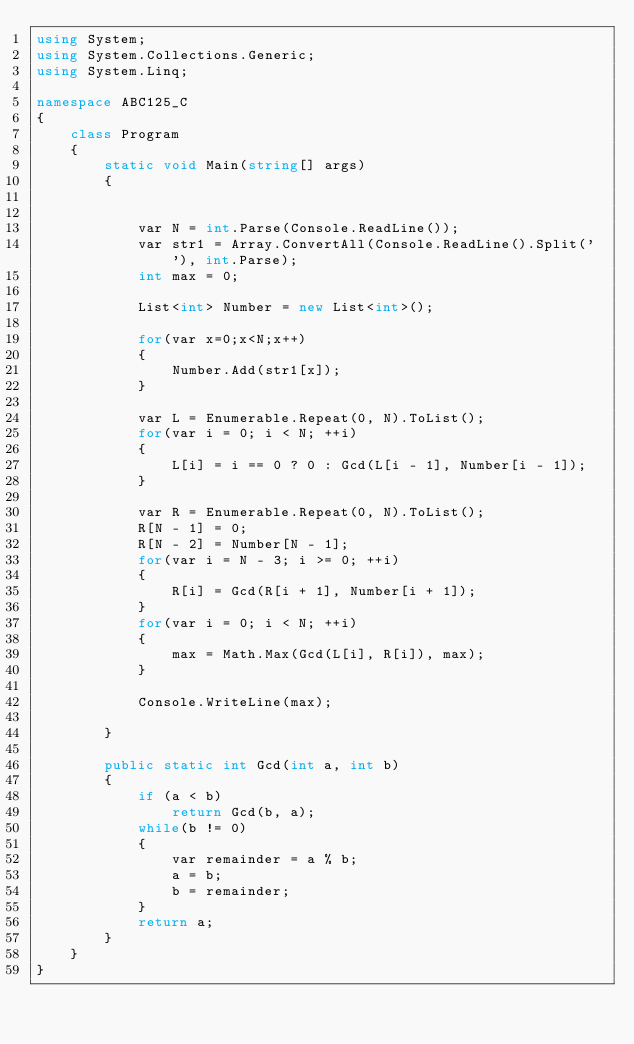Convert code to text. <code><loc_0><loc_0><loc_500><loc_500><_C#_>using System;
using System.Collections.Generic;
using System.Linq;

namespace ABC125_C
{
    class Program
    {
        static void Main(string[] args)
        {
            
            
            var N = int.Parse(Console.ReadLine());
            var str1 = Array.ConvertAll(Console.ReadLine().Split(' '), int.Parse);
            int max = 0;

            List<int> Number = new List<int>();
            
            for(var x=0;x<N;x++)
            {
                Number.Add(str1[x]);
            }

            var L = Enumerable.Repeat(0, N).ToList();
            for(var i = 0; i < N; ++i)
            {
                L[i] = i == 0 ? 0 : Gcd(L[i - 1], Number[i - 1]);
            }

            var R = Enumerable.Repeat(0, N).ToList();
            R[N - 1] = 0;
            R[N - 2] = Number[N - 1];
            for(var i = N - 3; i >= 0; ++i)
            {
                R[i] = Gcd(R[i + 1], Number[i + 1]);
            }
            for(var i = 0; i < N; ++i)
            {
                max = Math.Max(Gcd(L[i], R[i]), max);
            }

            Console.WriteLine(max);

        }

        public static int Gcd(int a, int b)
        {
            if (a < b)
                return Gcd(b, a);
            while(b != 0)
            {
                var remainder = a % b;
                a = b;
                b = remainder;
            }
            return a;
        }
    }
}
</code> 